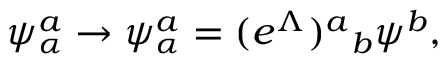<formula> <loc_0><loc_0><loc_500><loc_500>\psi _ { \alpha } ^ { a } \rightarrow \psi _ { \alpha } ^ { a } = ( e ^ { \Lambda } ^ { a _ { b } \psi ^ { b } ,</formula> 